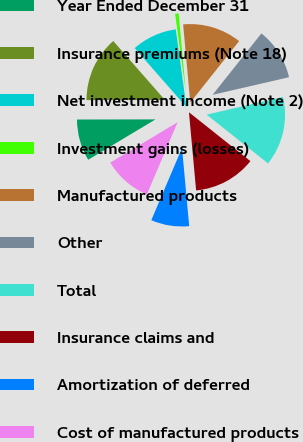Convert chart. <chart><loc_0><loc_0><loc_500><loc_500><pie_chart><fcel>Year Ended December 31<fcel>Insurance premiums (Note 18)<fcel>Net investment income (Note 2)<fcel>Investment gains (losses)<fcel>Manufactured products<fcel>Other<fcel>Total<fcel>Insurance claims and<fcel>Amortization of deferred<fcel>Cost of manufactured products<nl><fcel>8.57%<fcel>13.57%<fcel>9.29%<fcel>0.72%<fcel>12.14%<fcel>10.71%<fcel>14.29%<fcel>12.86%<fcel>7.86%<fcel>10.0%<nl></chart> 